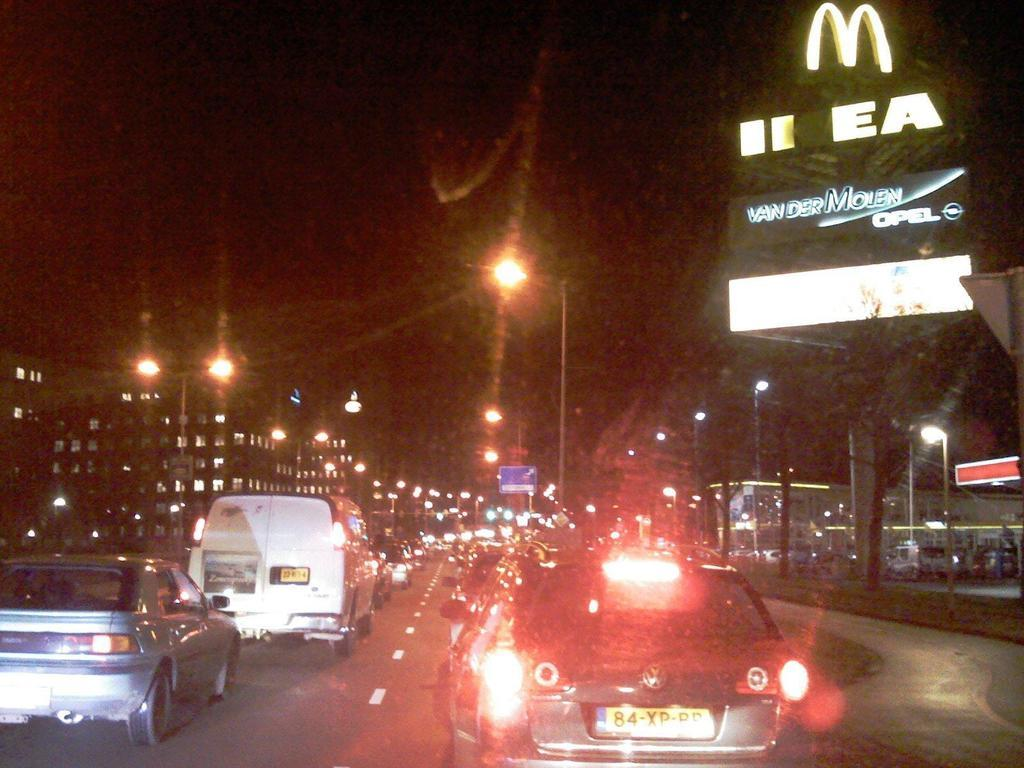What can be seen on the road in the image? There are many vehicles on the road in the image. What else is present on the road besides vehicles? There are light poles on the road in the image. What type of structures are visible on either side of the road? There are buildings on either side of the road in the image. Where is the school located in the image? There is no school present in the image. Can you tell me how many muscles are visible in the image? There are no muscles visible in the image. 